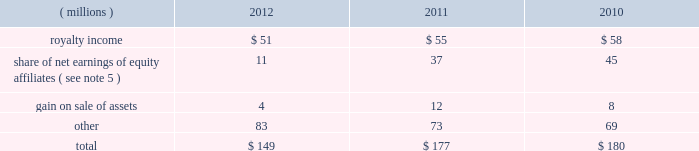68 2012 ppg annual report and form 10-k december 31 , 2012 , 2011 and 2010 was $ ( 30 ) million , $ 98 million and $ 65 million , respectively .
The cumulative tax benefit related to the adjustment for pension and other postretirement benefits at december 31 , 2012 and 2011 was approximately $ 960 million and $ 990 million , respectively .
There was no tax ( cost ) benefit related to the change in the unrealized gain ( loss ) on marketable securities for the year ended december 31 , 2012 .
The tax ( cost ) benefit related to the change in the unrealized gain ( loss ) on marketable securities for the years ended december 31 , 2011 and 2010 was $ ( 0.2 ) million and $ 0.6 million , respectively .
The tax benefit related to the change in the unrealized gain ( loss ) on derivatives for the years ended december 31 , 2012 , 2011 and 2010 was $ 4 million , $ 19 million and $ 1 million , respectively .
18 .
Employee savings plan ppg 2019s employee savings plan ( 201csavings plan 201d ) covers substantially all u.s .
Employees .
The company makes matching contributions to the savings plan , at management's discretion , based upon participants 2019 savings , subject to certain limitations .
For most participants not covered by a collective bargaining agreement , company-matching contributions are established each year at the discretion of the company and are applied to participant savings up to a maximum of 6% ( 6 % ) of eligible participant compensation .
For those participants whose employment is covered by a collective bargaining agreement , the level of company-matching contribution , if any , is determined by the relevant collective bargaining agreement .
The company-matching contribution was suspended from march 2009 through june 2010 as a cost savings measure in recognition of the adverse impact of the global recession .
Effective july 1 , 2010 , the company match was reinstated at 50% ( 50 % ) on the first 6% ( 6 % ) of compensation contributed for most employees eligible for the company-matching contribution feature .
This included the union represented employees in accordance with their collective bargaining agreements .
On january 1 , 2011 , the company match was increased to 75% ( 75 % ) on the first 6% ( 6 % ) of compensation contributed by these eligible employees and this level was maintained throughout 2012 .
Compensation expense and cash contributions related to the company match of participant contributions to the savings plan for 2012 , 2011 and 2010 totaled $ 28 million , $ 26 million and $ 9 million , respectively .
A portion of the savings plan qualifies under the internal revenue code as an employee stock ownership plan .
As a result , the dividends on ppg shares held by that portion of the savings plan totaling $ 18 million , $ 20 million and $ 24 million for 2012 , 2011 and 2010 , respectively , were tax deductible to the company for u.s .
Federal tax purposes .
19 .
Other earnings .
20 .
Stock-based compensation the company 2019s stock-based compensation includes stock options , restricted stock units ( 201crsus 201d ) and grants of contingent shares that are earned based on achieving targeted levels of total shareholder return .
All current grants of stock options , rsus and contingent shares are made under the ppg industries , inc .
Amended and restated omnibus incentive plan ( 201cppg amended omnibus plan 201d ) , which was amended and restated effective april 21 , 2011 .
Shares available for future grants under the ppg amended omnibus plan were 8.5 million as of december 31 , 2012 .
Total stock-based compensation cost was $ 73 million , $ 36 million and $ 52 million in 2012 , 2011 and 2010 , respectively .
Stock-based compensation expense increased year over year due to the increase in the expected payout percentage of the 2010 performance-based rsu grants and ppg's total shareholder return performance in 2012 in comparison with the standard & poors ( s&p ) 500 index , which has increased the expense related to outstanding grants of contingent shares .
The total income tax benefit recognized in the accompanying consolidated statement of income related to the stock-based compensation was $ 25 million , $ 13 million and $ 18 million in 2012 , 2011 and 2010 , respectively .
Stock options ppg has outstanding stock option awards that have been granted under two stock option plans : the ppg industries , inc .
Stock plan ( 201cppg stock plan 201d ) and the ppg amended omnibus plan .
Under the ppg amended omnibus plan and the ppg stock plan , certain employees of the company have been granted options to purchase shares of common stock at prices equal to the fair market value of the shares on the date the options were granted .
The options are generally exercisable beginning from six to 48 months after being granted and have a maximum term of 10 years .
Upon exercise of a stock option , shares of company stock are issued from treasury stock .
The ppg stock plan includes a restored option provision for options originally granted prior to january 1 , 2003 that allows an optionee to exercise options and satisfy the option cost by certifying ownership of mature shares of ppg common stock with a market value equal to the option cost .
The fair value of stock options issued to employees is measured on the date of grant and is recognized as expense over the requisite service period .
Ppg estimates the fair value of stock options using the black-scholes option pricing model .
The risk- free interest rate is determined by using the u.s .
Treasury yield table of contents .
What was the change in millions of total stock-based compensation cost from 2010 to 2011? 
Computations: (36 - 52)
Answer: -16.0. 